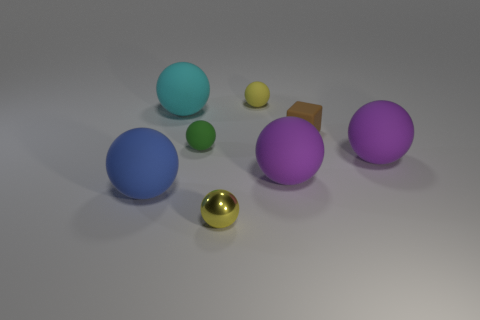Subtract all blue spheres. How many spheres are left? 6 Subtract 1 spheres. How many spheres are left? 6 Subtract all tiny shiny spheres. How many spheres are left? 6 Subtract all gray spheres. Subtract all red cylinders. How many spheres are left? 7 Add 2 green rubber balls. How many objects exist? 10 Subtract all balls. How many objects are left? 1 Subtract 0 green blocks. How many objects are left? 8 Subtract all small cyan rubber objects. Subtract all cyan matte things. How many objects are left? 7 Add 4 tiny yellow metallic objects. How many tiny yellow metallic objects are left? 5 Add 1 blue spheres. How many blue spheres exist? 2 